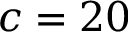Convert formula to latex. <formula><loc_0><loc_0><loc_500><loc_500>c = 2 0</formula> 